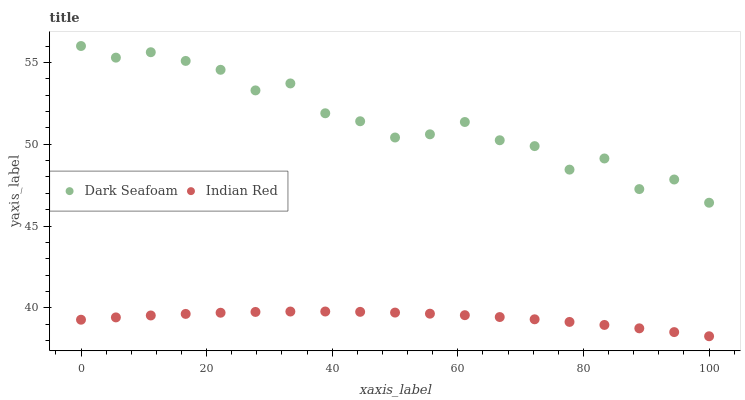Does Indian Red have the minimum area under the curve?
Answer yes or no. Yes. Does Dark Seafoam have the maximum area under the curve?
Answer yes or no. Yes. Does Indian Red have the maximum area under the curve?
Answer yes or no. No. Is Indian Red the smoothest?
Answer yes or no. Yes. Is Dark Seafoam the roughest?
Answer yes or no. Yes. Is Indian Red the roughest?
Answer yes or no. No. Does Indian Red have the lowest value?
Answer yes or no. Yes. Does Dark Seafoam have the highest value?
Answer yes or no. Yes. Does Indian Red have the highest value?
Answer yes or no. No. Is Indian Red less than Dark Seafoam?
Answer yes or no. Yes. Is Dark Seafoam greater than Indian Red?
Answer yes or no. Yes. Does Indian Red intersect Dark Seafoam?
Answer yes or no. No. 